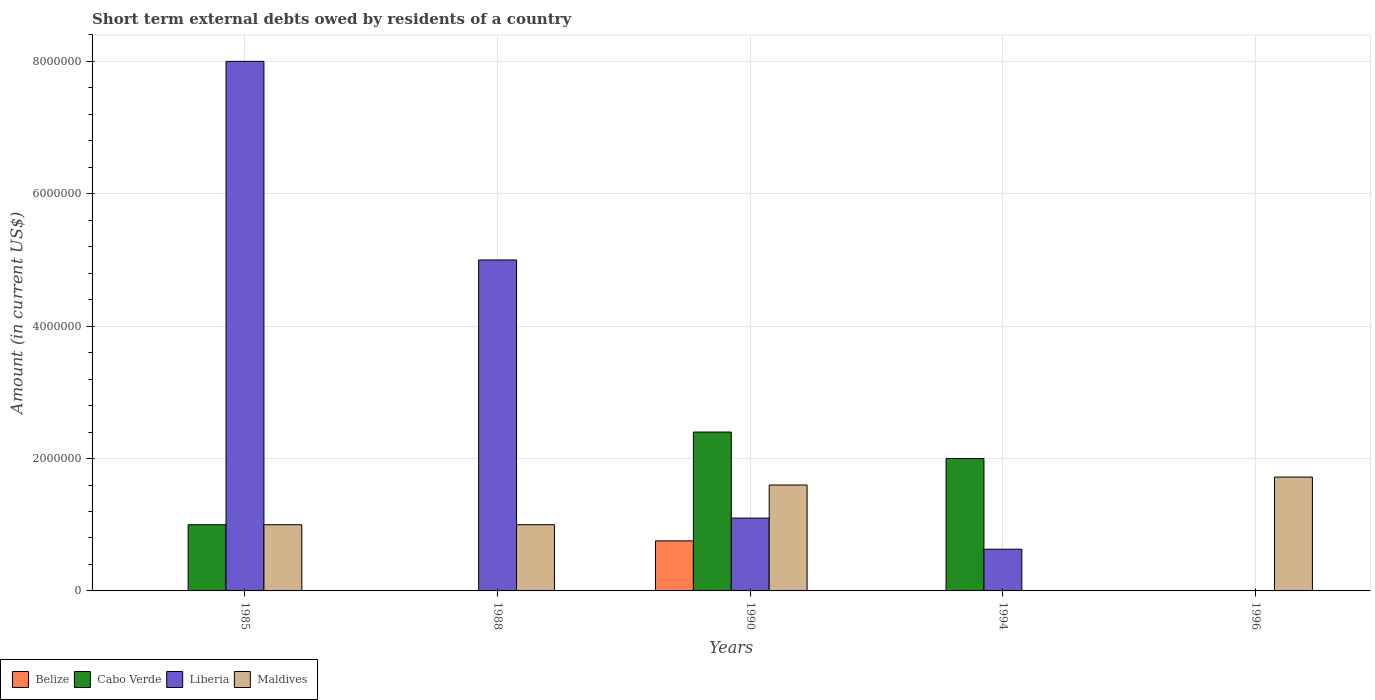How many bars are there on the 5th tick from the left?
Provide a succinct answer. 1. How many bars are there on the 1st tick from the right?
Provide a succinct answer. 1. What is the label of the 1st group of bars from the left?
Give a very brief answer. 1985. In how many cases, is the number of bars for a given year not equal to the number of legend labels?
Give a very brief answer. 4. What is the amount of short-term external debts owed by residents in Liberia in 1988?
Provide a short and direct response. 5.00e+06. Across all years, what is the maximum amount of short-term external debts owed by residents in Maldives?
Offer a terse response. 1.72e+06. What is the total amount of short-term external debts owed by residents in Liberia in the graph?
Your answer should be very brief. 1.47e+07. What is the difference between the amount of short-term external debts owed by residents in Maldives in 1990 and that in 1996?
Offer a terse response. -1.20e+05. What is the difference between the amount of short-term external debts owed by residents in Cabo Verde in 1988 and the amount of short-term external debts owed by residents in Belize in 1990?
Make the answer very short. -7.56e+05. What is the average amount of short-term external debts owed by residents in Liberia per year?
Provide a succinct answer. 2.95e+06. In the year 1990, what is the difference between the amount of short-term external debts owed by residents in Liberia and amount of short-term external debts owed by residents in Cabo Verde?
Ensure brevity in your answer.  -1.30e+06. In how many years, is the amount of short-term external debts owed by residents in Belize greater than 1600000 US$?
Keep it short and to the point. 0. What is the ratio of the amount of short-term external debts owed by residents in Maldives in 1988 to that in 1996?
Provide a short and direct response. 0.58. What is the difference between the highest and the second highest amount of short-term external debts owed by residents in Maldives?
Ensure brevity in your answer.  1.20e+05. What is the difference between the highest and the lowest amount of short-term external debts owed by residents in Maldives?
Give a very brief answer. 1.72e+06. In how many years, is the amount of short-term external debts owed by residents in Maldives greater than the average amount of short-term external debts owed by residents in Maldives taken over all years?
Make the answer very short. 2. Is the sum of the amount of short-term external debts owed by residents in Liberia in 1990 and 1994 greater than the maximum amount of short-term external debts owed by residents in Belize across all years?
Provide a short and direct response. Yes. Is it the case that in every year, the sum of the amount of short-term external debts owed by residents in Maldives and amount of short-term external debts owed by residents in Liberia is greater than the amount of short-term external debts owed by residents in Cabo Verde?
Your answer should be compact. No. What is the difference between two consecutive major ticks on the Y-axis?
Your answer should be very brief. 2.00e+06. How many legend labels are there?
Provide a short and direct response. 4. How are the legend labels stacked?
Your answer should be compact. Horizontal. What is the title of the graph?
Keep it short and to the point. Short term external debts owed by residents of a country. Does "Kuwait" appear as one of the legend labels in the graph?
Offer a very short reply. No. What is the label or title of the Y-axis?
Provide a succinct answer. Amount (in current US$). What is the Amount (in current US$) in Cabo Verde in 1985?
Ensure brevity in your answer.  1.00e+06. What is the Amount (in current US$) of Liberia in 1985?
Make the answer very short. 8.00e+06. What is the Amount (in current US$) of Maldives in 1985?
Provide a short and direct response. 1.00e+06. What is the Amount (in current US$) of Belize in 1988?
Offer a very short reply. 0. What is the Amount (in current US$) of Maldives in 1988?
Provide a short and direct response. 1.00e+06. What is the Amount (in current US$) in Belize in 1990?
Ensure brevity in your answer.  7.56e+05. What is the Amount (in current US$) of Cabo Verde in 1990?
Provide a short and direct response. 2.40e+06. What is the Amount (in current US$) in Liberia in 1990?
Make the answer very short. 1.10e+06. What is the Amount (in current US$) in Maldives in 1990?
Keep it short and to the point. 1.60e+06. What is the Amount (in current US$) of Liberia in 1994?
Keep it short and to the point. 6.30e+05. What is the Amount (in current US$) of Belize in 1996?
Your answer should be very brief. 0. What is the Amount (in current US$) of Cabo Verde in 1996?
Provide a succinct answer. 0. What is the Amount (in current US$) in Maldives in 1996?
Your answer should be compact. 1.72e+06. Across all years, what is the maximum Amount (in current US$) in Belize?
Make the answer very short. 7.56e+05. Across all years, what is the maximum Amount (in current US$) in Cabo Verde?
Your answer should be compact. 2.40e+06. Across all years, what is the maximum Amount (in current US$) in Maldives?
Give a very brief answer. 1.72e+06. Across all years, what is the minimum Amount (in current US$) in Belize?
Offer a terse response. 0. Across all years, what is the minimum Amount (in current US$) in Liberia?
Keep it short and to the point. 0. Across all years, what is the minimum Amount (in current US$) of Maldives?
Give a very brief answer. 0. What is the total Amount (in current US$) in Belize in the graph?
Make the answer very short. 7.56e+05. What is the total Amount (in current US$) in Cabo Verde in the graph?
Ensure brevity in your answer.  5.40e+06. What is the total Amount (in current US$) of Liberia in the graph?
Make the answer very short. 1.47e+07. What is the total Amount (in current US$) of Maldives in the graph?
Offer a very short reply. 5.32e+06. What is the difference between the Amount (in current US$) in Cabo Verde in 1985 and that in 1990?
Your answer should be very brief. -1.40e+06. What is the difference between the Amount (in current US$) of Liberia in 1985 and that in 1990?
Keep it short and to the point. 6.90e+06. What is the difference between the Amount (in current US$) in Maldives in 1985 and that in 1990?
Ensure brevity in your answer.  -6.00e+05. What is the difference between the Amount (in current US$) in Cabo Verde in 1985 and that in 1994?
Keep it short and to the point. -1.00e+06. What is the difference between the Amount (in current US$) of Liberia in 1985 and that in 1994?
Offer a very short reply. 7.37e+06. What is the difference between the Amount (in current US$) of Maldives in 1985 and that in 1996?
Ensure brevity in your answer.  -7.20e+05. What is the difference between the Amount (in current US$) of Liberia in 1988 and that in 1990?
Ensure brevity in your answer.  3.90e+06. What is the difference between the Amount (in current US$) of Maldives in 1988 and that in 1990?
Provide a short and direct response. -6.00e+05. What is the difference between the Amount (in current US$) in Liberia in 1988 and that in 1994?
Ensure brevity in your answer.  4.37e+06. What is the difference between the Amount (in current US$) of Maldives in 1988 and that in 1996?
Give a very brief answer. -7.20e+05. What is the difference between the Amount (in current US$) in Liberia in 1985 and the Amount (in current US$) in Maldives in 1988?
Your answer should be compact. 7.00e+06. What is the difference between the Amount (in current US$) in Cabo Verde in 1985 and the Amount (in current US$) in Maldives in 1990?
Provide a succinct answer. -6.00e+05. What is the difference between the Amount (in current US$) in Liberia in 1985 and the Amount (in current US$) in Maldives in 1990?
Ensure brevity in your answer.  6.40e+06. What is the difference between the Amount (in current US$) of Cabo Verde in 1985 and the Amount (in current US$) of Maldives in 1996?
Give a very brief answer. -7.20e+05. What is the difference between the Amount (in current US$) of Liberia in 1985 and the Amount (in current US$) of Maldives in 1996?
Provide a short and direct response. 6.28e+06. What is the difference between the Amount (in current US$) in Liberia in 1988 and the Amount (in current US$) in Maldives in 1990?
Offer a terse response. 3.40e+06. What is the difference between the Amount (in current US$) in Liberia in 1988 and the Amount (in current US$) in Maldives in 1996?
Offer a very short reply. 3.28e+06. What is the difference between the Amount (in current US$) of Belize in 1990 and the Amount (in current US$) of Cabo Verde in 1994?
Give a very brief answer. -1.24e+06. What is the difference between the Amount (in current US$) of Belize in 1990 and the Amount (in current US$) of Liberia in 1994?
Make the answer very short. 1.26e+05. What is the difference between the Amount (in current US$) of Cabo Verde in 1990 and the Amount (in current US$) of Liberia in 1994?
Give a very brief answer. 1.77e+06. What is the difference between the Amount (in current US$) in Belize in 1990 and the Amount (in current US$) in Maldives in 1996?
Give a very brief answer. -9.64e+05. What is the difference between the Amount (in current US$) in Cabo Verde in 1990 and the Amount (in current US$) in Maldives in 1996?
Keep it short and to the point. 6.80e+05. What is the difference between the Amount (in current US$) in Liberia in 1990 and the Amount (in current US$) in Maldives in 1996?
Make the answer very short. -6.20e+05. What is the difference between the Amount (in current US$) of Cabo Verde in 1994 and the Amount (in current US$) of Maldives in 1996?
Give a very brief answer. 2.80e+05. What is the difference between the Amount (in current US$) of Liberia in 1994 and the Amount (in current US$) of Maldives in 1996?
Make the answer very short. -1.09e+06. What is the average Amount (in current US$) of Belize per year?
Your answer should be very brief. 1.51e+05. What is the average Amount (in current US$) of Cabo Verde per year?
Provide a short and direct response. 1.08e+06. What is the average Amount (in current US$) of Liberia per year?
Provide a succinct answer. 2.95e+06. What is the average Amount (in current US$) in Maldives per year?
Keep it short and to the point. 1.06e+06. In the year 1985, what is the difference between the Amount (in current US$) in Cabo Verde and Amount (in current US$) in Liberia?
Your response must be concise. -7.00e+06. In the year 1985, what is the difference between the Amount (in current US$) of Liberia and Amount (in current US$) of Maldives?
Your answer should be very brief. 7.00e+06. In the year 1990, what is the difference between the Amount (in current US$) of Belize and Amount (in current US$) of Cabo Verde?
Provide a succinct answer. -1.64e+06. In the year 1990, what is the difference between the Amount (in current US$) of Belize and Amount (in current US$) of Liberia?
Make the answer very short. -3.44e+05. In the year 1990, what is the difference between the Amount (in current US$) of Belize and Amount (in current US$) of Maldives?
Offer a terse response. -8.44e+05. In the year 1990, what is the difference between the Amount (in current US$) of Cabo Verde and Amount (in current US$) of Liberia?
Offer a terse response. 1.30e+06. In the year 1990, what is the difference between the Amount (in current US$) in Liberia and Amount (in current US$) in Maldives?
Your response must be concise. -5.00e+05. In the year 1994, what is the difference between the Amount (in current US$) of Cabo Verde and Amount (in current US$) of Liberia?
Your answer should be very brief. 1.37e+06. What is the ratio of the Amount (in current US$) in Liberia in 1985 to that in 1988?
Give a very brief answer. 1.6. What is the ratio of the Amount (in current US$) of Maldives in 1985 to that in 1988?
Offer a very short reply. 1. What is the ratio of the Amount (in current US$) of Cabo Verde in 1985 to that in 1990?
Your answer should be compact. 0.42. What is the ratio of the Amount (in current US$) in Liberia in 1985 to that in 1990?
Your answer should be very brief. 7.27. What is the ratio of the Amount (in current US$) in Liberia in 1985 to that in 1994?
Give a very brief answer. 12.7. What is the ratio of the Amount (in current US$) in Maldives in 1985 to that in 1996?
Keep it short and to the point. 0.58. What is the ratio of the Amount (in current US$) in Liberia in 1988 to that in 1990?
Your answer should be compact. 4.55. What is the ratio of the Amount (in current US$) of Liberia in 1988 to that in 1994?
Keep it short and to the point. 7.94. What is the ratio of the Amount (in current US$) in Maldives in 1988 to that in 1996?
Keep it short and to the point. 0.58. What is the ratio of the Amount (in current US$) of Liberia in 1990 to that in 1994?
Provide a short and direct response. 1.75. What is the ratio of the Amount (in current US$) of Maldives in 1990 to that in 1996?
Offer a very short reply. 0.93. What is the difference between the highest and the second highest Amount (in current US$) of Liberia?
Your response must be concise. 3.00e+06. What is the difference between the highest and the second highest Amount (in current US$) of Maldives?
Offer a very short reply. 1.20e+05. What is the difference between the highest and the lowest Amount (in current US$) in Belize?
Make the answer very short. 7.56e+05. What is the difference between the highest and the lowest Amount (in current US$) of Cabo Verde?
Your answer should be very brief. 2.40e+06. What is the difference between the highest and the lowest Amount (in current US$) of Maldives?
Offer a very short reply. 1.72e+06. 